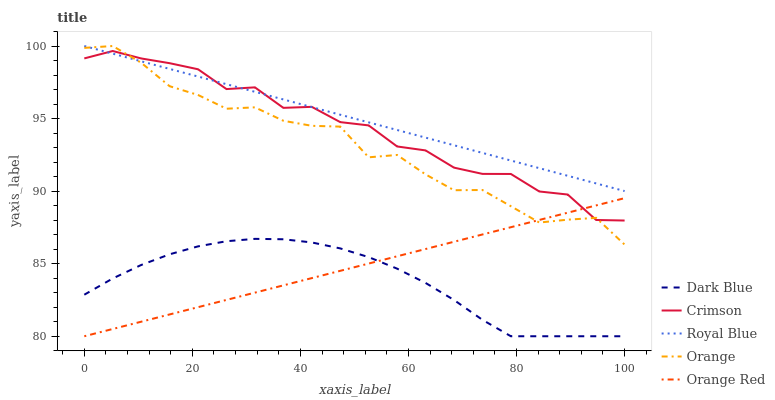Does Orange have the minimum area under the curve?
Answer yes or no. No. Does Orange have the maximum area under the curve?
Answer yes or no. No. Is Dark Blue the smoothest?
Answer yes or no. No. Is Dark Blue the roughest?
Answer yes or no. No. Does Orange have the lowest value?
Answer yes or no. No. Does Dark Blue have the highest value?
Answer yes or no. No. Is Orange Red less than Royal Blue?
Answer yes or no. Yes. Is Royal Blue greater than Dark Blue?
Answer yes or no. Yes. Does Orange Red intersect Royal Blue?
Answer yes or no. No. 